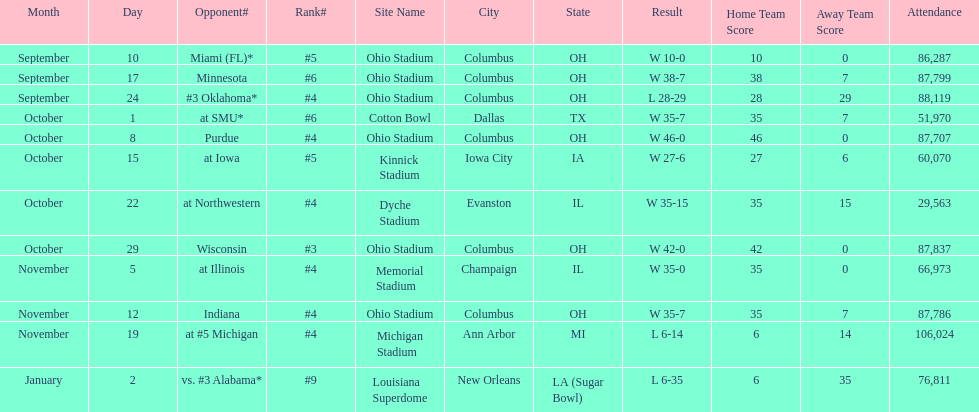How many games did this team win during this season? 9. 